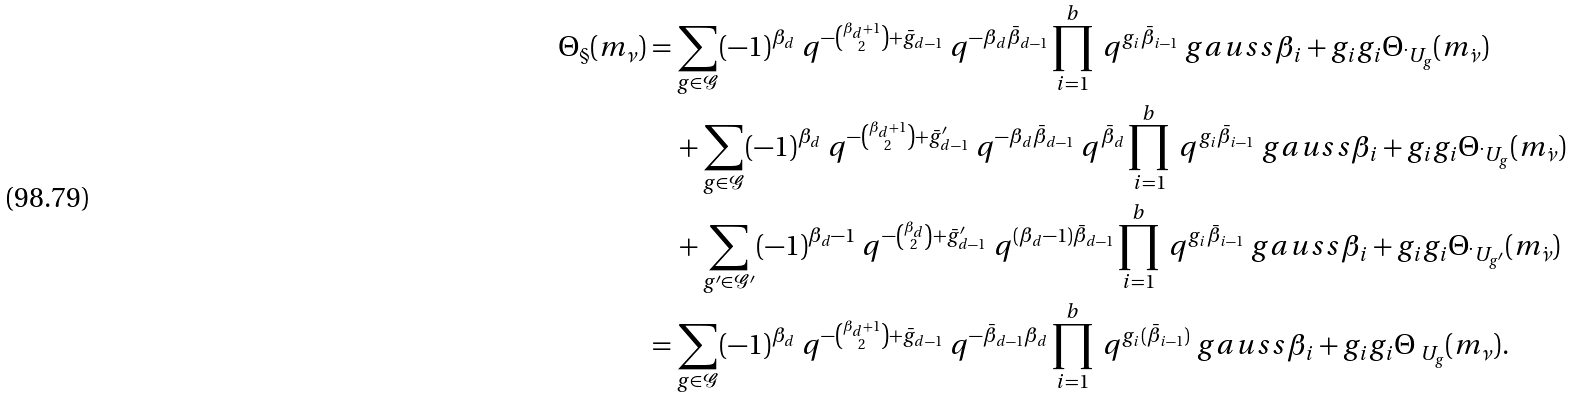<formula> <loc_0><loc_0><loc_500><loc_500>\Theta _ { \S } ( m _ { \nu } ) & = \sum _ { g \in \mathcal { G } } ( - 1 ) ^ { \beta _ { d } } \ q ^ { - \binom { \beta _ { d } + 1 } { 2 } + \bar { g } _ { d - 1 } } \ q ^ { - \beta _ { d } \bar { \beta } _ { d - 1 } } \prod _ { i = 1 } ^ { b } \ q ^ { g _ { i } \bar { \beta } _ { i - 1 } } \ g a u s s { \beta _ { i } + g _ { i } } { g _ { i } } \Theta _ { \dot { \ } U _ { g } } ( m _ { \dot { \nu } } ) \\ & \quad + \sum _ { g \in \mathcal { G } } ( - 1 ) ^ { \beta _ { d } } \ q ^ { - \binom { \beta _ { d } + 1 } { 2 } + \bar { g } ^ { \prime } _ { d - 1 } } \ q ^ { - \beta _ { d } \bar { \beta } _ { d - 1 } } \ q ^ { \bar { \beta } _ { d } } \prod _ { i = 1 } ^ { b } \ q ^ { g _ { i } \bar { \beta } _ { i - 1 } } \ g a u s s { \beta _ { i } + g _ { i } } { g _ { i } } \Theta _ { \dot { \ } U _ { g } } ( m _ { \dot { \nu } } ) \\ & \quad + \sum _ { g ^ { \prime } \in \mathcal { G ^ { \prime } } } ( - 1 ) ^ { \beta _ { d } - 1 } \ q ^ { - \binom { \beta _ { d } } { 2 } + \bar { g } ^ { \prime } _ { d - 1 } } \ q ^ { ( \beta _ { d } - 1 ) \bar { \beta } _ { d - 1 } } \prod _ { i = 1 } ^ { b } \ q ^ { g _ { i } \bar { \beta } _ { i - 1 } } \ g a u s s { \beta _ { i } + g _ { i } } { g _ { i } } \Theta _ { \dot { \ } U _ { g ^ { \prime } } } ( m _ { \dot { \nu } } ) \\ & = \sum _ { g \in \mathcal { G } } ( - 1 ) ^ { \beta _ { d } } \ q ^ { - \binom { \beta _ { d } + 1 } { 2 } + \bar { g } _ { d - 1 } } \ q ^ { - \bar { \beta } _ { d - 1 } \beta _ { d } } \prod _ { i = 1 } ^ { b } \ q ^ { g _ { i } ( \bar { \beta } _ { i - 1 } ) } \ g a u s s { \beta _ { i } + g _ { i } } { g _ { i } } \Theta _ { \ U _ { g } } ( m _ { \nu } ) .</formula> 